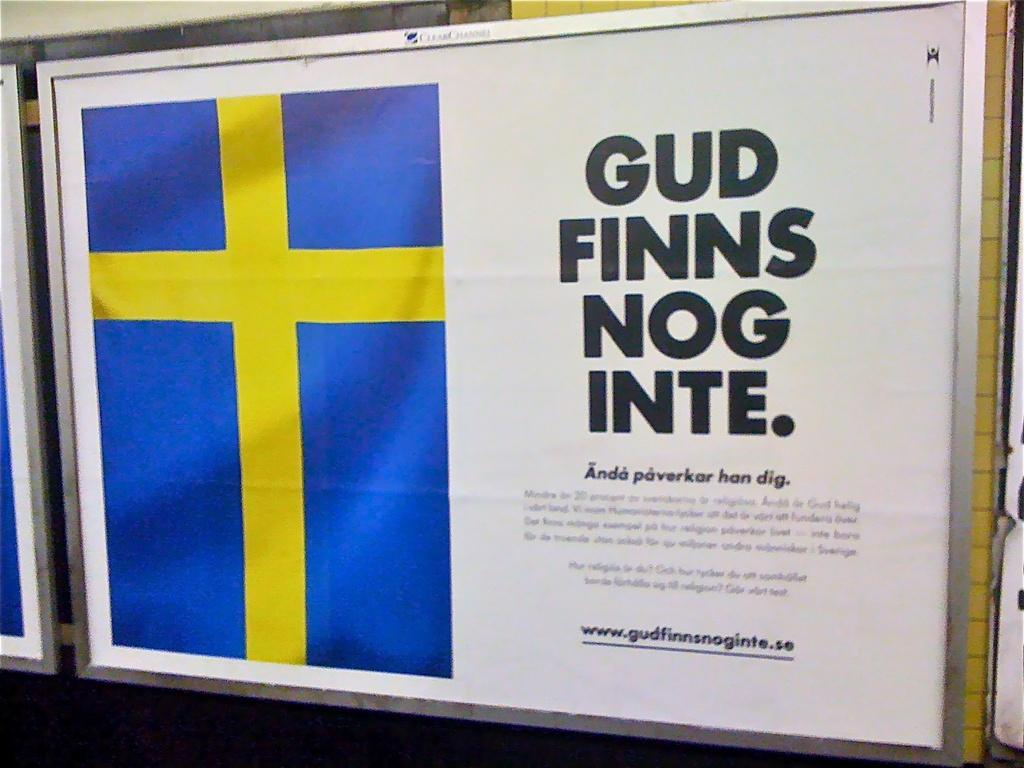<image>
Offer a succinct explanation of the picture presented. a billboard that says 'gud finns nog inte.' on it 